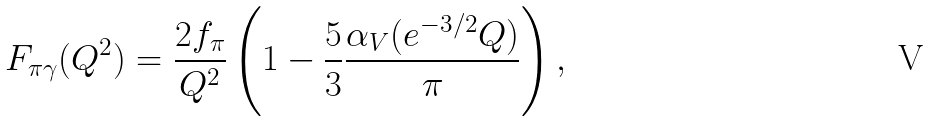<formula> <loc_0><loc_0><loc_500><loc_500>F _ { \pi \gamma } ( Q ^ { 2 } ) = \frac { 2 f _ { \pi } } { Q ^ { 2 } } \left ( 1 - \frac { 5 } { 3 } \frac { \alpha _ { V } ( e ^ { - 3 / 2 } Q ) } { \pi } \right ) ,</formula> 